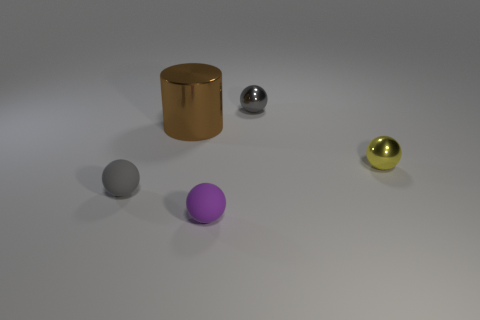Subtract all purple spheres. How many spheres are left? 3 Subtract all yellow blocks. How many gray spheres are left? 2 Subtract all purple spheres. How many spheres are left? 3 Add 1 small purple matte things. How many objects exist? 6 Subtract 2 spheres. How many spheres are left? 2 Subtract all balls. How many objects are left? 1 Subtract all yellow spheres. Subtract all green blocks. How many spheres are left? 3 Subtract all rubber objects. Subtract all tiny shiny things. How many objects are left? 1 Add 5 metal balls. How many metal balls are left? 7 Add 3 brown things. How many brown things exist? 4 